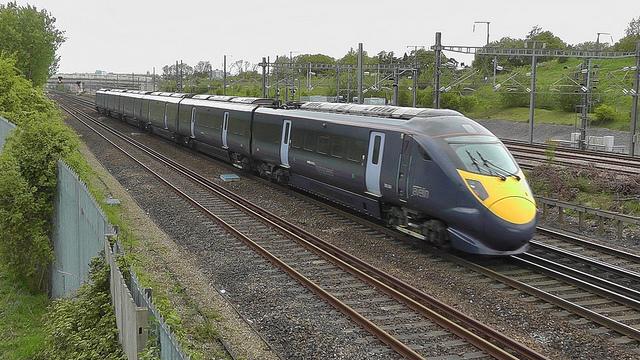Is this a steam engine?
Be succinct. No. What is the train doing in the photograph?
Give a very brief answer. Moving. How many sets of tracks are there?
Give a very brief answer. 3. How many tracks can be seen?
Write a very short answer. 3. 